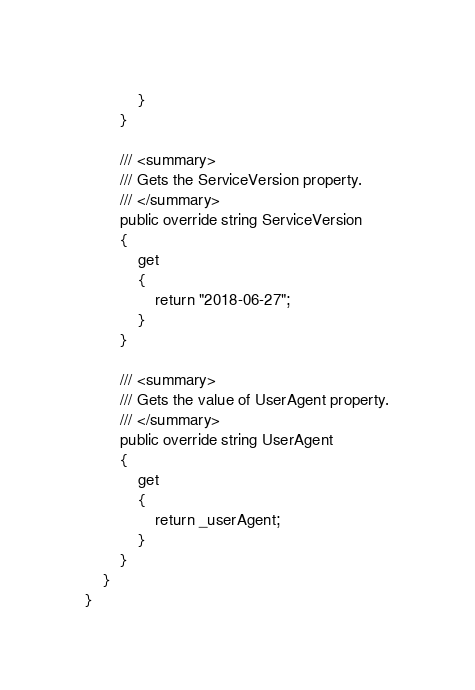<code> <loc_0><loc_0><loc_500><loc_500><_C#_>            }
        }

        /// <summary>
        /// Gets the ServiceVersion property.
        /// </summary>
        public override string ServiceVersion
        {
            get
            {
                return "2018-06-27";
            }
        }

        /// <summary>
        /// Gets the value of UserAgent property.
        /// </summary>
        public override string UserAgent
        {
            get
            {
                return _userAgent;
            }
        }
    }
}</code> 